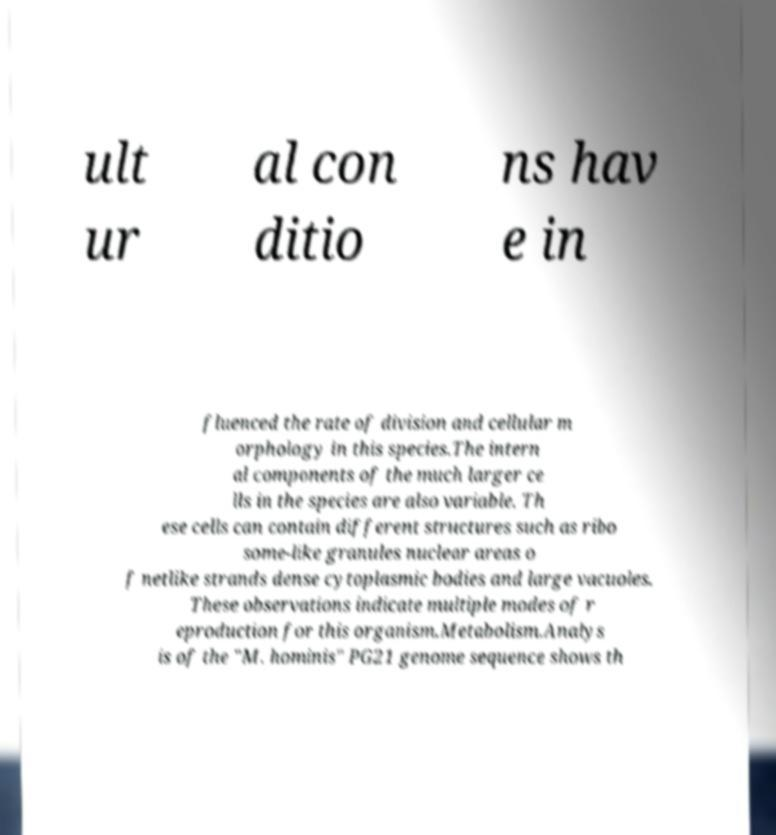Could you assist in decoding the text presented in this image and type it out clearly? ult ur al con ditio ns hav e in fluenced the rate of division and cellular m orphology in this species.The intern al components of the much larger ce lls in the species are also variable. Th ese cells can contain different structures such as ribo some-like granules nuclear areas o f netlike strands dense cytoplasmic bodies and large vacuoles. These observations indicate multiple modes of r eproduction for this organism.Metabolism.Analys is of the "M. hominis" PG21 genome sequence shows th 